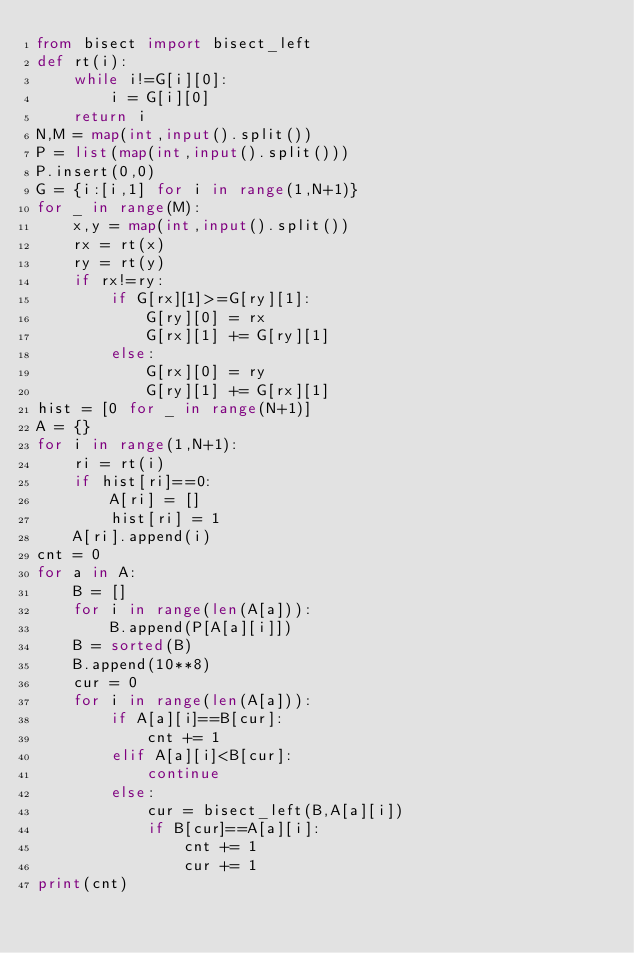Convert code to text. <code><loc_0><loc_0><loc_500><loc_500><_Python_>from bisect import bisect_left
def rt(i):
    while i!=G[i][0]:
        i = G[i][0]
    return i
N,M = map(int,input().split())
P = list(map(int,input().split()))
P.insert(0,0)
G = {i:[i,1] for i in range(1,N+1)}
for _ in range(M):
    x,y = map(int,input().split())
    rx = rt(x)
    ry = rt(y)
    if rx!=ry:
        if G[rx][1]>=G[ry][1]:
            G[ry][0] = rx
            G[rx][1] += G[ry][1]
        else:
            G[rx][0] = ry
            G[ry][1] += G[rx][1]
hist = [0 for _ in range(N+1)]
A = {}
for i in range(1,N+1):
    ri = rt(i)
    if hist[ri]==0:
        A[ri] = []
        hist[ri] = 1
    A[ri].append(i)
cnt = 0
for a in A:
    B = []
    for i in range(len(A[a])):
        B.append(P[A[a][i]])
    B = sorted(B)
    B.append(10**8)
    cur = 0
    for i in range(len(A[a])):
        if A[a][i]==B[cur]:
            cnt += 1
        elif A[a][i]<B[cur]:
            continue
        else:
            cur = bisect_left(B,A[a][i])
            if B[cur]==A[a][i]:
                cnt += 1
                cur += 1
print(cnt)</code> 